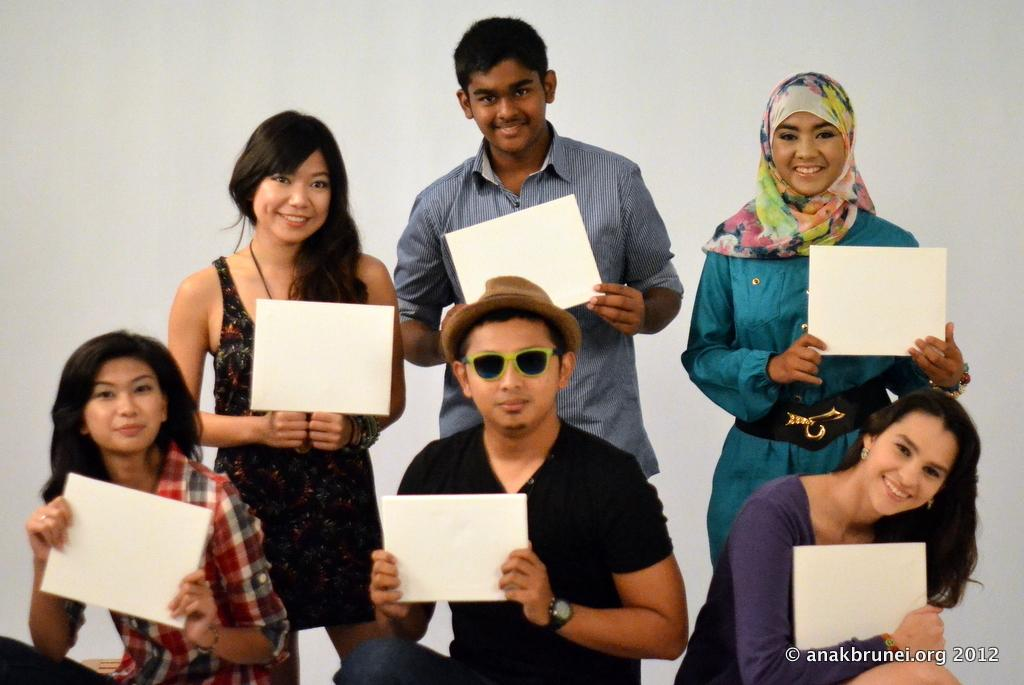How many people are in the image? There are persons in the image, but the exact number is not specified. What can be seen in the background of the image? The background of the image is white. What are the persons wearing in the image? The persons are wearing clothes in the image. What are the persons holding in the image? The persons are holding placards with their hands in the image. What type of education is being promoted by the pigs in the image? There are no pigs present in the image; it features persons holding placards. What industry is depicted in the image? The image does not depict any specific industry; it shows persons holding placards. 